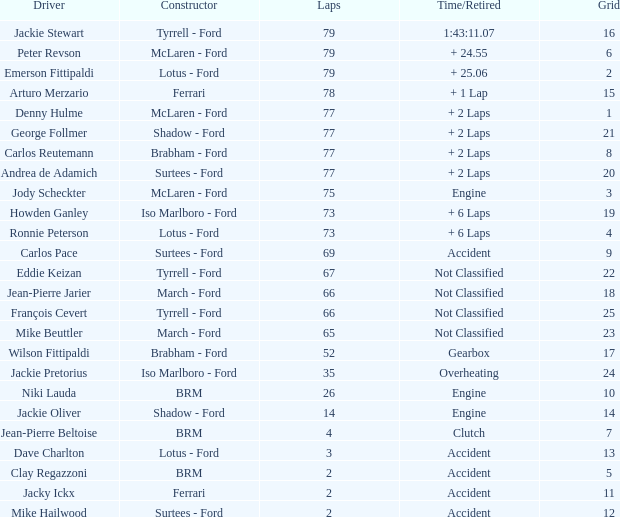What is the duration needed to complete fewer than 35 laps and under 10 grids? Clutch, Accident. 